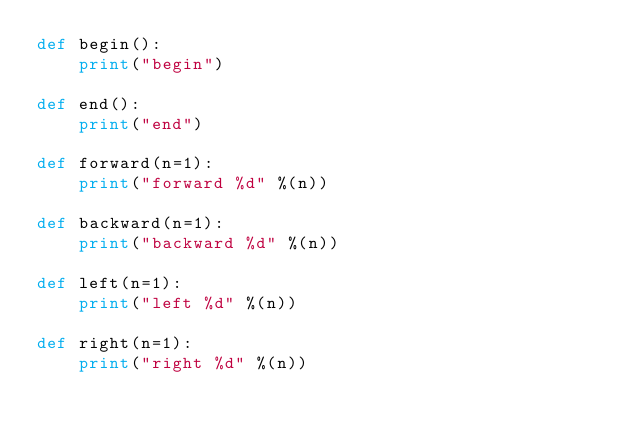Convert code to text. <code><loc_0><loc_0><loc_500><loc_500><_Python_>def begin():
    print("begin")

def end():
    print("end")

def forward(n=1):
    print("forward %d" %(n))

def backward(n=1):
    print("backward %d" %(n))

def left(n=1):
    print("left %d" %(n))

def right(n=1):
    print("right %d" %(n))


</code> 